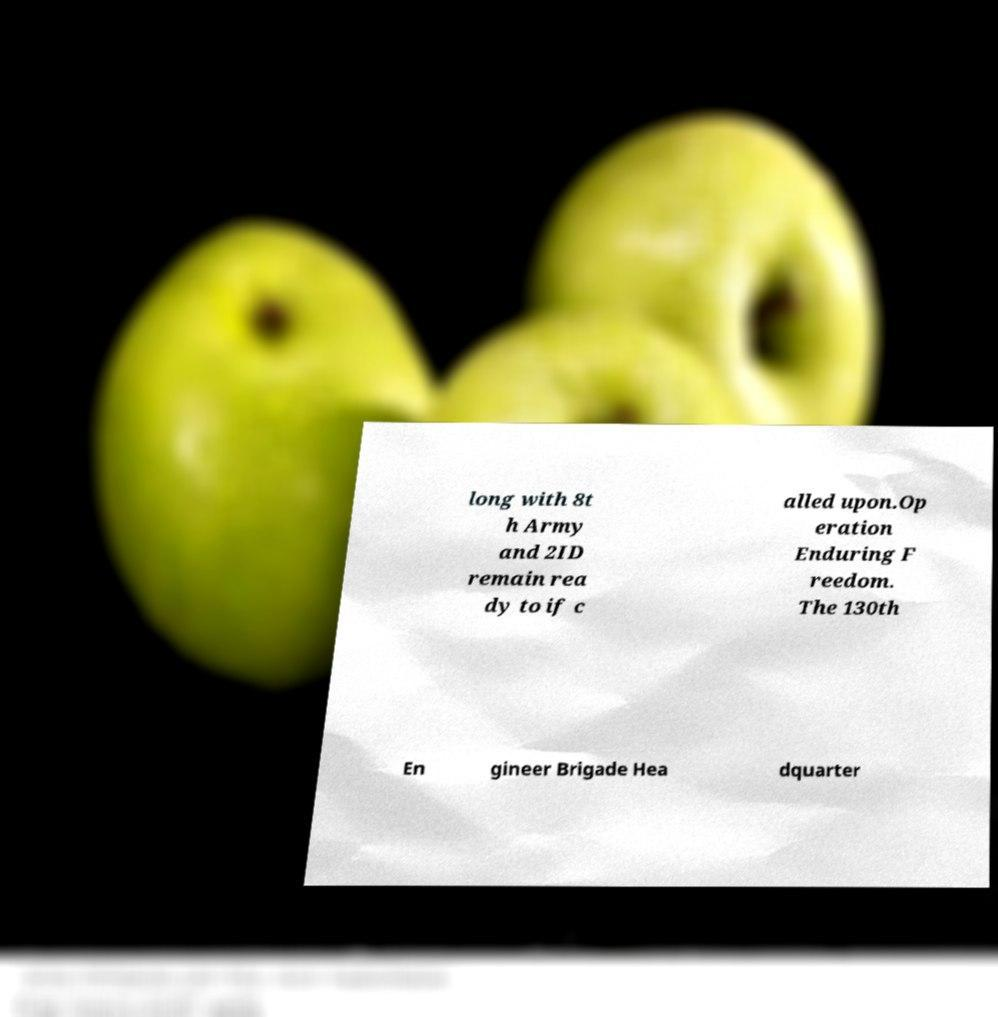Please identify and transcribe the text found in this image. long with 8t h Army and 2ID remain rea dy to if c alled upon.Op eration Enduring F reedom. The 130th En gineer Brigade Hea dquarter 